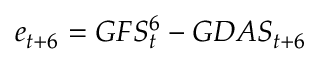<formula> <loc_0><loc_0><loc_500><loc_500>e _ { t + 6 } = G F S _ { t } ^ { 6 } - G D A S _ { t + 6 }</formula> 